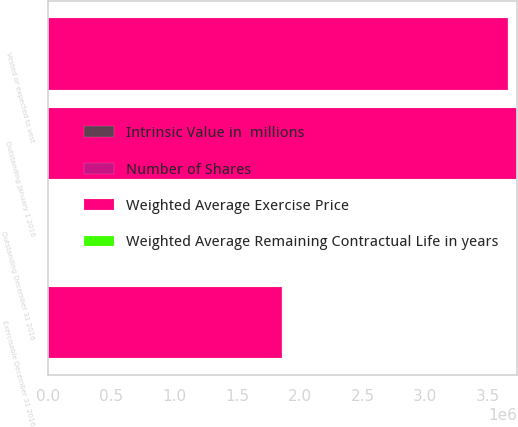<chart> <loc_0><loc_0><loc_500><loc_500><stacked_bar_chart><ecel><fcel>Outstanding January 1 2016<fcel>Outstanding December 31 2016<fcel>Vested or expected to vest<fcel>Exercisable December 31 2016<nl><fcel>Weighted Average Exercise Price<fcel>3.72973e+06<fcel>75.84<fcel>3.65774e+06<fcel>1.85934e+06<nl><fcel>Number of Shares<fcel>67.68<fcel>75.84<fcel>66.9<fcel>48.43<nl><fcel>Weighted Average Remaining Contractual Life in years<fcel>6.5<fcel>6.5<fcel>6.4<fcel>4.6<nl><fcel>Intrinsic Value in  millions<fcel>127<fcel>86<fcel>86<fcel>86<nl></chart> 